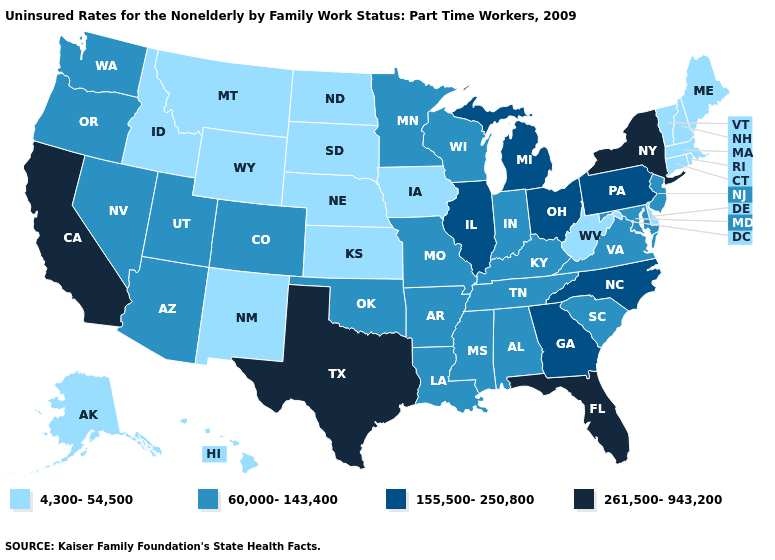Which states have the highest value in the USA?
Answer briefly. California, Florida, New York, Texas. Does the first symbol in the legend represent the smallest category?
Write a very short answer. Yes. What is the value of Illinois?
Answer briefly. 155,500-250,800. What is the value of Wyoming?
Write a very short answer. 4,300-54,500. What is the highest value in the MidWest ?
Concise answer only. 155,500-250,800. Does the first symbol in the legend represent the smallest category?
Keep it brief. Yes. Name the states that have a value in the range 261,500-943,200?
Keep it brief. California, Florida, New York, Texas. Name the states that have a value in the range 155,500-250,800?
Keep it brief. Georgia, Illinois, Michigan, North Carolina, Ohio, Pennsylvania. Name the states that have a value in the range 60,000-143,400?
Concise answer only. Alabama, Arizona, Arkansas, Colorado, Indiana, Kentucky, Louisiana, Maryland, Minnesota, Mississippi, Missouri, Nevada, New Jersey, Oklahoma, Oregon, South Carolina, Tennessee, Utah, Virginia, Washington, Wisconsin. What is the value of Missouri?
Write a very short answer. 60,000-143,400. What is the value of Kansas?
Quick response, please. 4,300-54,500. Name the states that have a value in the range 155,500-250,800?
Be succinct. Georgia, Illinois, Michigan, North Carolina, Ohio, Pennsylvania. How many symbols are there in the legend?
Keep it brief. 4. Name the states that have a value in the range 4,300-54,500?
Concise answer only. Alaska, Connecticut, Delaware, Hawaii, Idaho, Iowa, Kansas, Maine, Massachusetts, Montana, Nebraska, New Hampshire, New Mexico, North Dakota, Rhode Island, South Dakota, Vermont, West Virginia, Wyoming. 